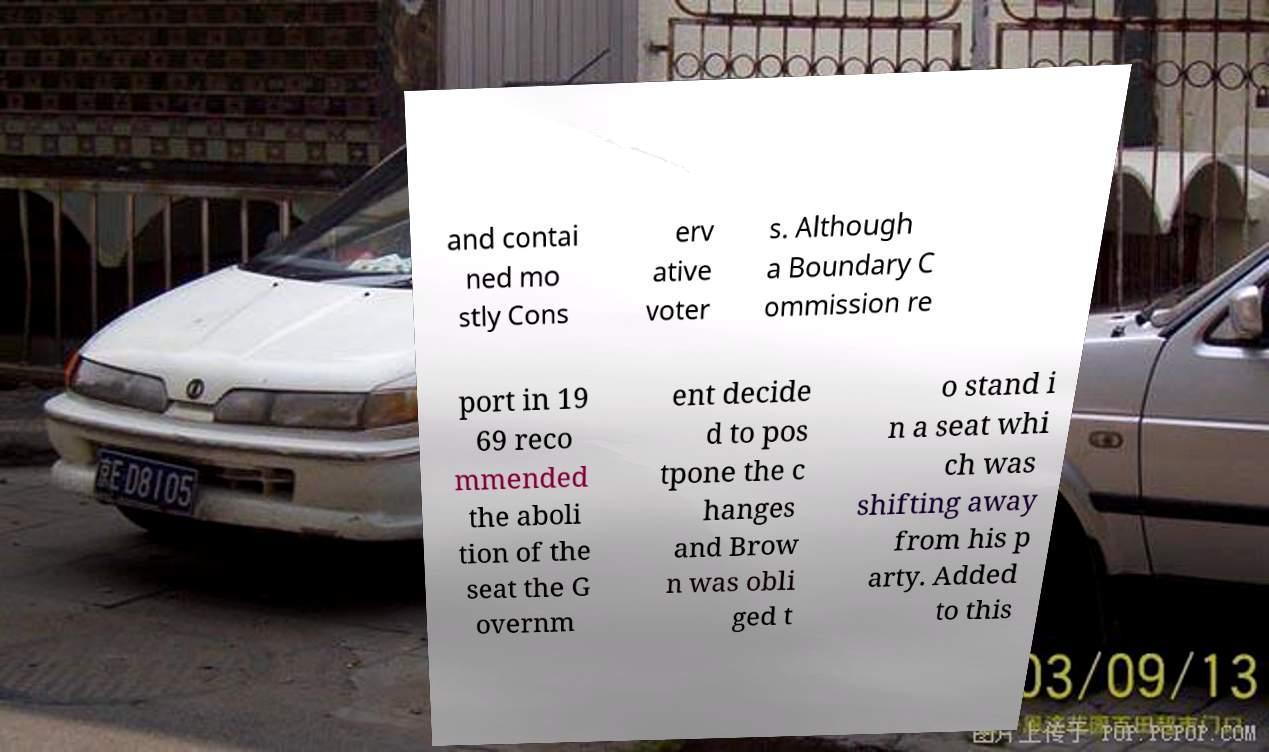Can you accurately transcribe the text from the provided image for me? and contai ned mo stly Cons erv ative voter s. Although a Boundary C ommission re port in 19 69 reco mmended the aboli tion of the seat the G overnm ent decide d to pos tpone the c hanges and Brow n was obli ged t o stand i n a seat whi ch was shifting away from his p arty. Added to this 